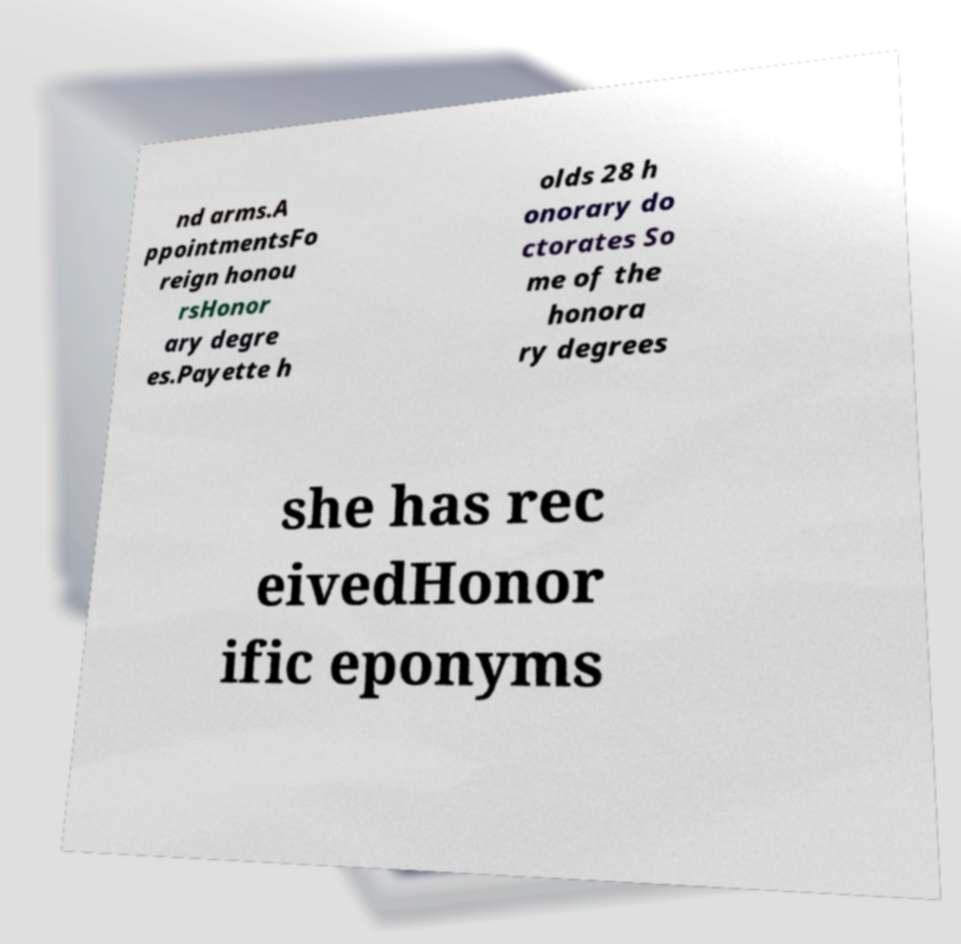There's text embedded in this image that I need extracted. Can you transcribe it verbatim? nd arms.A ppointmentsFo reign honou rsHonor ary degre es.Payette h olds 28 h onorary do ctorates So me of the honora ry degrees she has rec eivedHonor ific eponyms 